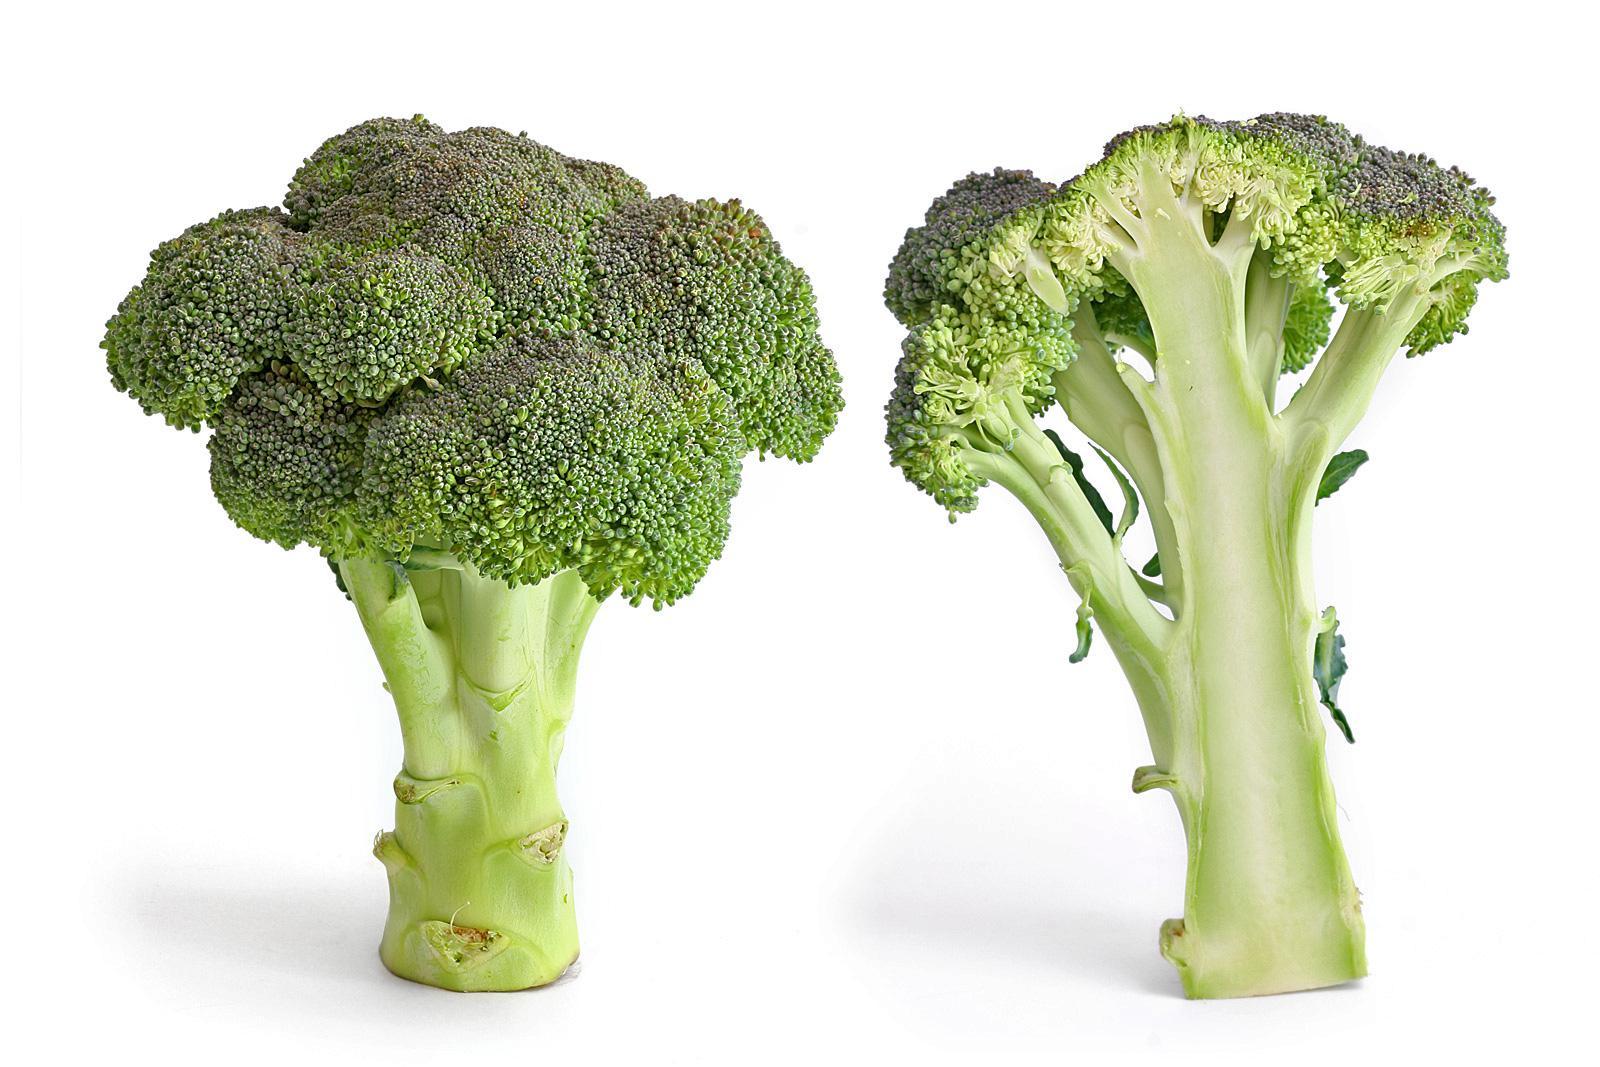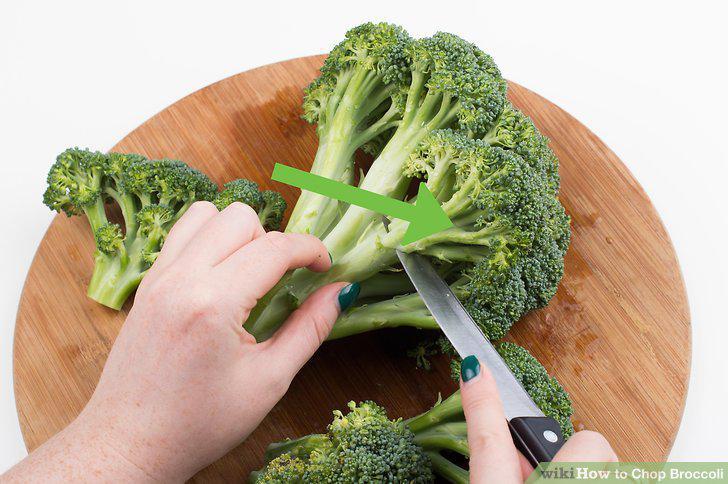The first image is the image on the left, the second image is the image on the right. For the images displayed, is the sentence "One image shows broccoli on a wooden cutting board." factually correct? Answer yes or no. Yes. 